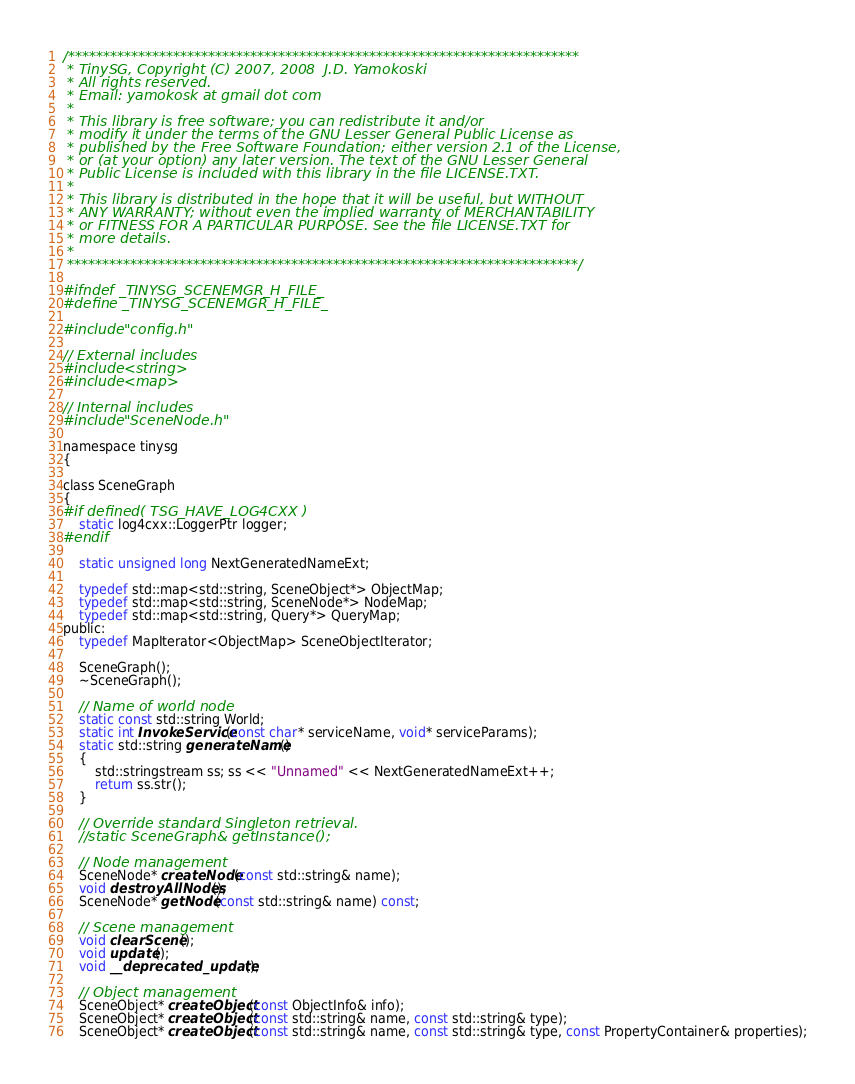Convert code to text. <code><loc_0><loc_0><loc_500><loc_500><_C_>/*************************************************************************
 * TinySG, Copyright (C) 2007, 2008  J.D. Yamokoski
 * All rights reserved.
 * Email: yamokosk at gmail dot com
 *
 * This library is free software; you can redistribute it and/or
 * modify it under the terms of the GNU Lesser General Public License as
 * published by the Free Software Foundation; either version 2.1 of the License,
 * or (at your option) any later version. The text of the GNU Lesser General
 * Public License is included with this library in the file LICENSE.TXT.
 *
 * This library is distributed in the hope that it will be useful, but WITHOUT
 * ANY WARRANTY; without even the implied warranty of MERCHANTABILITY
 * or FITNESS FOR A PARTICULAR PURPOSE. See the file LICENSE.TXT for
 * more details.
 *
 *************************************************************************/

#ifndef _TINYSG_SCENEMGR_H_FILE_
#define _TINYSG_SCENEMGR_H_FILE_

#include "config.h"

// External includes
#include <string>
#include <map>

// Internal includes
#include "SceneNode.h"

namespace tinysg
{

class SceneGraph
{
#if defined( TSG_HAVE_LOG4CXX )
	static log4cxx::LoggerPtr logger;
#endif

	static unsigned long NextGeneratedNameExt;

	typedef std::map<std::string, SceneObject*> ObjectMap;
	typedef std::map<std::string, SceneNode*> NodeMap;
	typedef std::map<std::string, Query*> QueryMap;
public:
	typedef MapIterator<ObjectMap> SceneObjectIterator;

	SceneGraph();
	~SceneGraph();

	// Name of world node
	static const std::string World;
	static int InvokeService(const char* serviceName, void* serviceParams);
	static std::string generateName()
	{
		std::stringstream ss; ss << "Unnamed" << NextGeneratedNameExt++;
		return ss.str();
	}

	// Override standard Singleton retrieval.
	//static SceneGraph& getInstance();

	// Node management
	SceneNode* createNode(const std::string& name);
	void destroyAllNodes();
	SceneNode* getNode(const std::string& name) const;

	// Scene management
	void clearScene();
	void update();
	void __deprecated_update();

	// Object management
	SceneObject* createObject(const ObjectInfo& info);
	SceneObject* createObject(const std::string& name, const std::string& type);
	SceneObject* createObject(const std::string& name, const std::string& type, const PropertyContainer& properties);</code> 